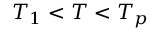Convert formula to latex. <formula><loc_0><loc_0><loc_500><loc_500>T _ { 1 } < T < T _ { p }</formula> 